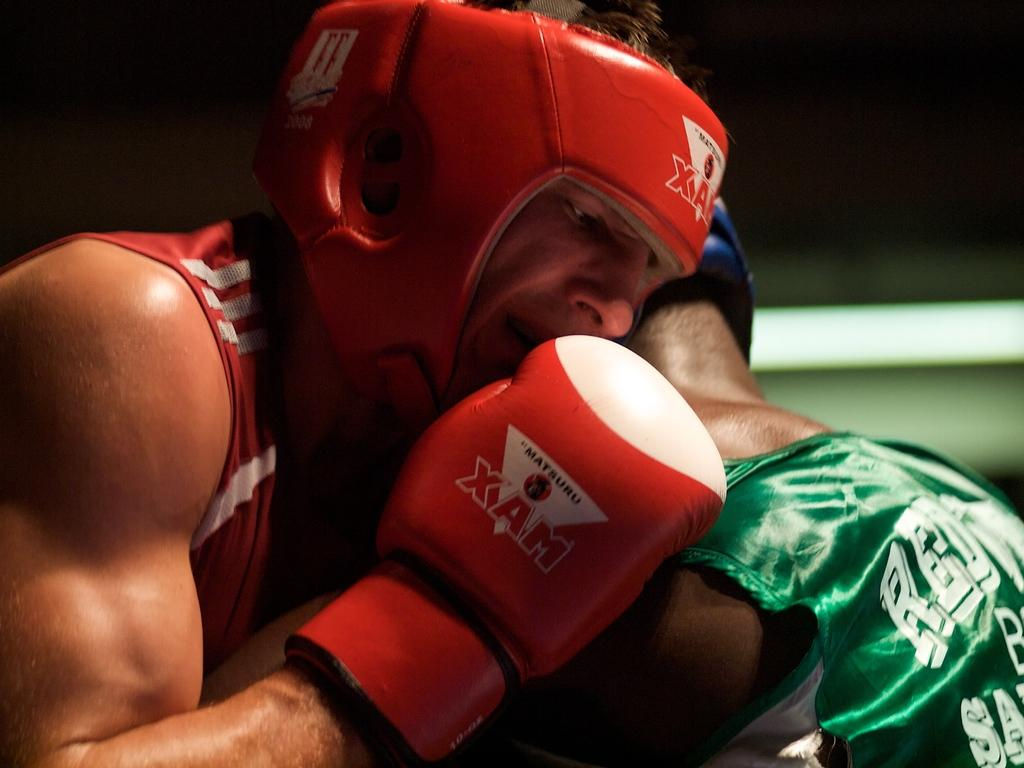<image>
Render a clear and concise summary of the photo. Two boxers are locked together, one sporting a glove titled "XAM." 